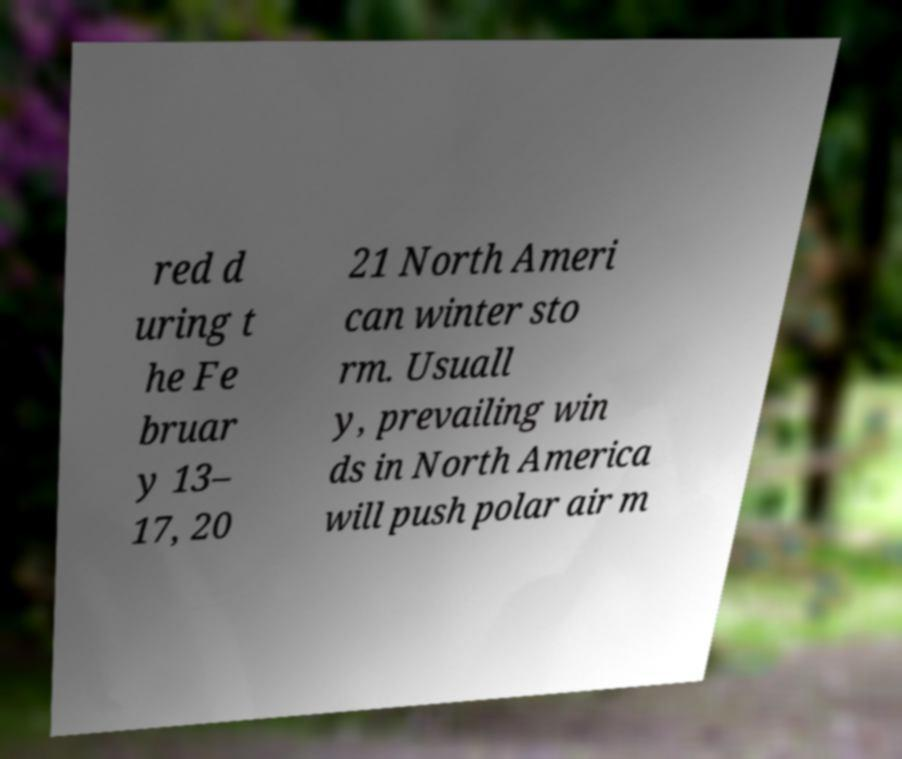I need the written content from this picture converted into text. Can you do that? red d uring t he Fe bruar y 13– 17, 20 21 North Ameri can winter sto rm. Usuall y, prevailing win ds in North America will push polar air m 